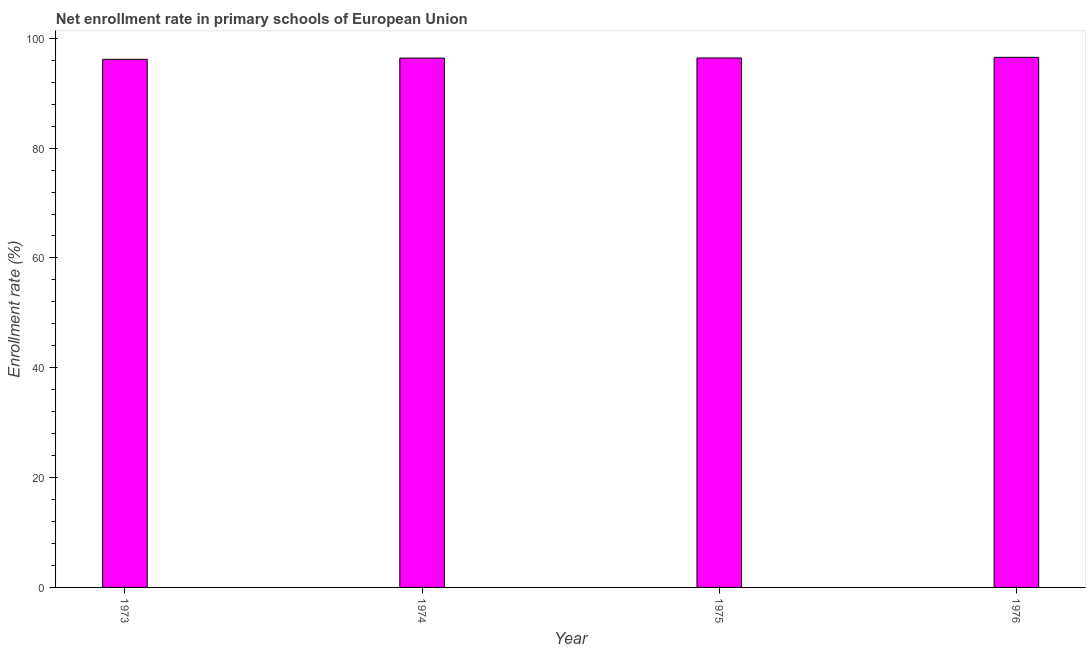Does the graph contain any zero values?
Your response must be concise. No. Does the graph contain grids?
Provide a succinct answer. No. What is the title of the graph?
Give a very brief answer. Net enrollment rate in primary schools of European Union. What is the label or title of the X-axis?
Provide a succinct answer. Year. What is the label or title of the Y-axis?
Your answer should be compact. Enrollment rate (%). What is the net enrollment rate in primary schools in 1974?
Provide a short and direct response. 96.39. Across all years, what is the maximum net enrollment rate in primary schools?
Provide a succinct answer. 96.53. Across all years, what is the minimum net enrollment rate in primary schools?
Ensure brevity in your answer.  96.17. In which year was the net enrollment rate in primary schools maximum?
Ensure brevity in your answer.  1976. What is the sum of the net enrollment rate in primary schools?
Offer a very short reply. 385.51. What is the difference between the net enrollment rate in primary schools in 1973 and 1976?
Your response must be concise. -0.37. What is the average net enrollment rate in primary schools per year?
Offer a very short reply. 96.38. What is the median net enrollment rate in primary schools?
Your answer should be very brief. 96.4. Do a majority of the years between 1976 and 1975 (inclusive) have net enrollment rate in primary schools greater than 20 %?
Your response must be concise. No. Is the net enrollment rate in primary schools in 1973 less than that in 1974?
Keep it short and to the point. Yes. What is the difference between the highest and the second highest net enrollment rate in primary schools?
Make the answer very short. 0.12. What is the difference between the highest and the lowest net enrollment rate in primary schools?
Your response must be concise. 0.37. In how many years, is the net enrollment rate in primary schools greater than the average net enrollment rate in primary schools taken over all years?
Your answer should be very brief. 3. Are all the bars in the graph horizontal?
Provide a succinct answer. No. How many years are there in the graph?
Offer a terse response. 4. Are the values on the major ticks of Y-axis written in scientific E-notation?
Offer a very short reply. No. What is the Enrollment rate (%) of 1973?
Give a very brief answer. 96.17. What is the Enrollment rate (%) of 1974?
Provide a succinct answer. 96.39. What is the Enrollment rate (%) in 1975?
Your answer should be very brief. 96.42. What is the Enrollment rate (%) of 1976?
Give a very brief answer. 96.53. What is the difference between the Enrollment rate (%) in 1973 and 1974?
Keep it short and to the point. -0.22. What is the difference between the Enrollment rate (%) in 1973 and 1975?
Provide a short and direct response. -0.25. What is the difference between the Enrollment rate (%) in 1973 and 1976?
Your answer should be very brief. -0.37. What is the difference between the Enrollment rate (%) in 1974 and 1975?
Provide a succinct answer. -0.02. What is the difference between the Enrollment rate (%) in 1974 and 1976?
Keep it short and to the point. -0.14. What is the difference between the Enrollment rate (%) in 1975 and 1976?
Keep it short and to the point. -0.12. What is the ratio of the Enrollment rate (%) in 1973 to that in 1976?
Keep it short and to the point. 1. What is the ratio of the Enrollment rate (%) in 1974 to that in 1975?
Provide a succinct answer. 1. What is the ratio of the Enrollment rate (%) in 1975 to that in 1976?
Ensure brevity in your answer.  1. 